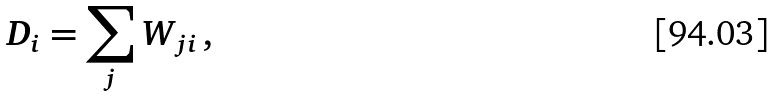Convert formula to latex. <formula><loc_0><loc_0><loc_500><loc_500>D _ { i } = \sum _ { j } W _ { j i } \, ,</formula> 